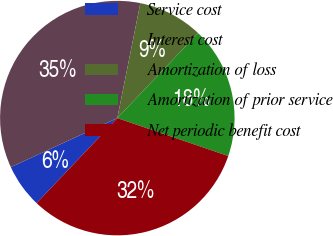Convert chart to OTSL. <chart><loc_0><loc_0><loc_500><loc_500><pie_chart><fcel>Service cost<fcel>Interest cost<fcel>Amortization of loss<fcel>Amortization of prior service<fcel>Net periodic benefit cost<nl><fcel>6.05%<fcel>35.02%<fcel>8.95%<fcel>18.15%<fcel>31.84%<nl></chart> 